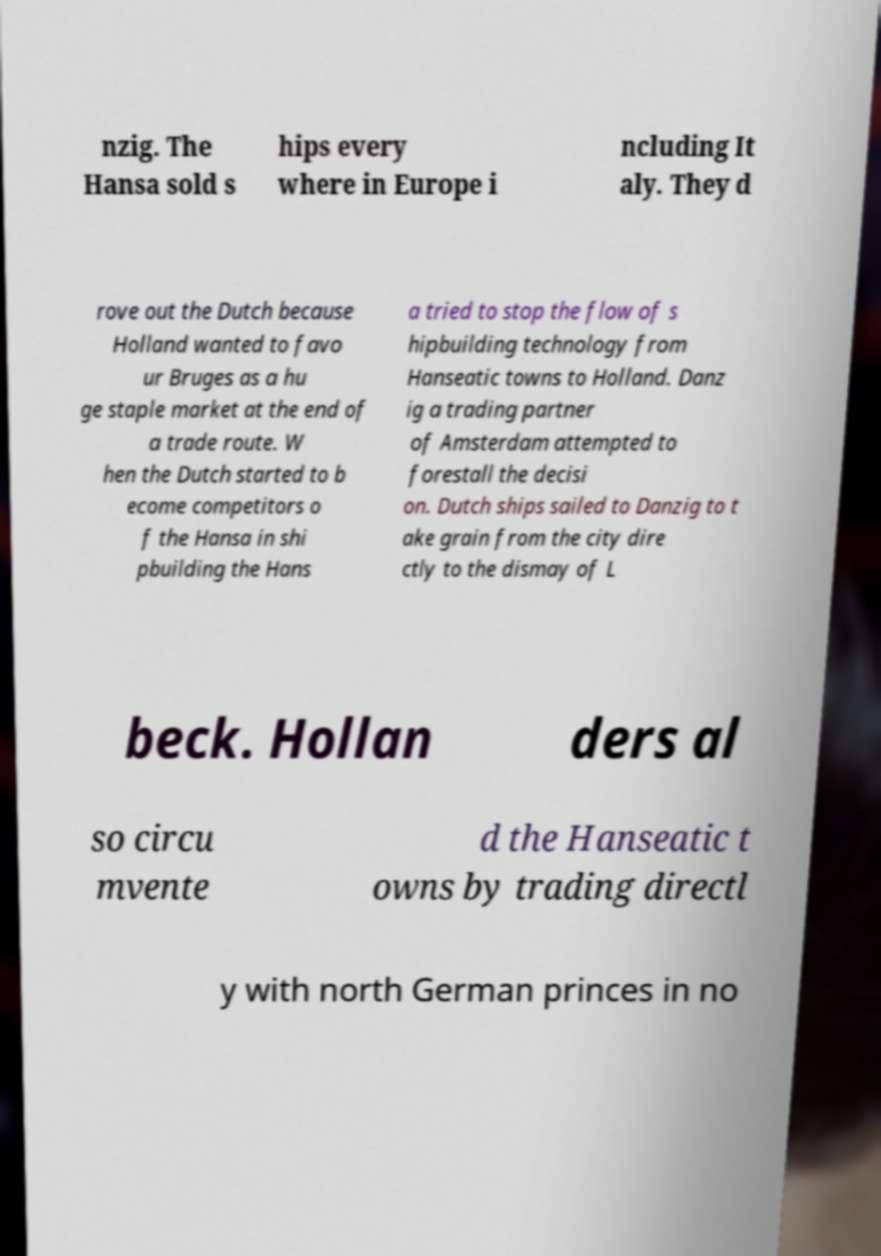What messages or text are displayed in this image? I need them in a readable, typed format. nzig. The Hansa sold s hips every where in Europe i ncluding It aly. They d rove out the Dutch because Holland wanted to favo ur Bruges as a hu ge staple market at the end of a trade route. W hen the Dutch started to b ecome competitors o f the Hansa in shi pbuilding the Hans a tried to stop the flow of s hipbuilding technology from Hanseatic towns to Holland. Danz ig a trading partner of Amsterdam attempted to forestall the decisi on. Dutch ships sailed to Danzig to t ake grain from the city dire ctly to the dismay of L beck. Hollan ders al so circu mvente d the Hanseatic t owns by trading directl y with north German princes in no 